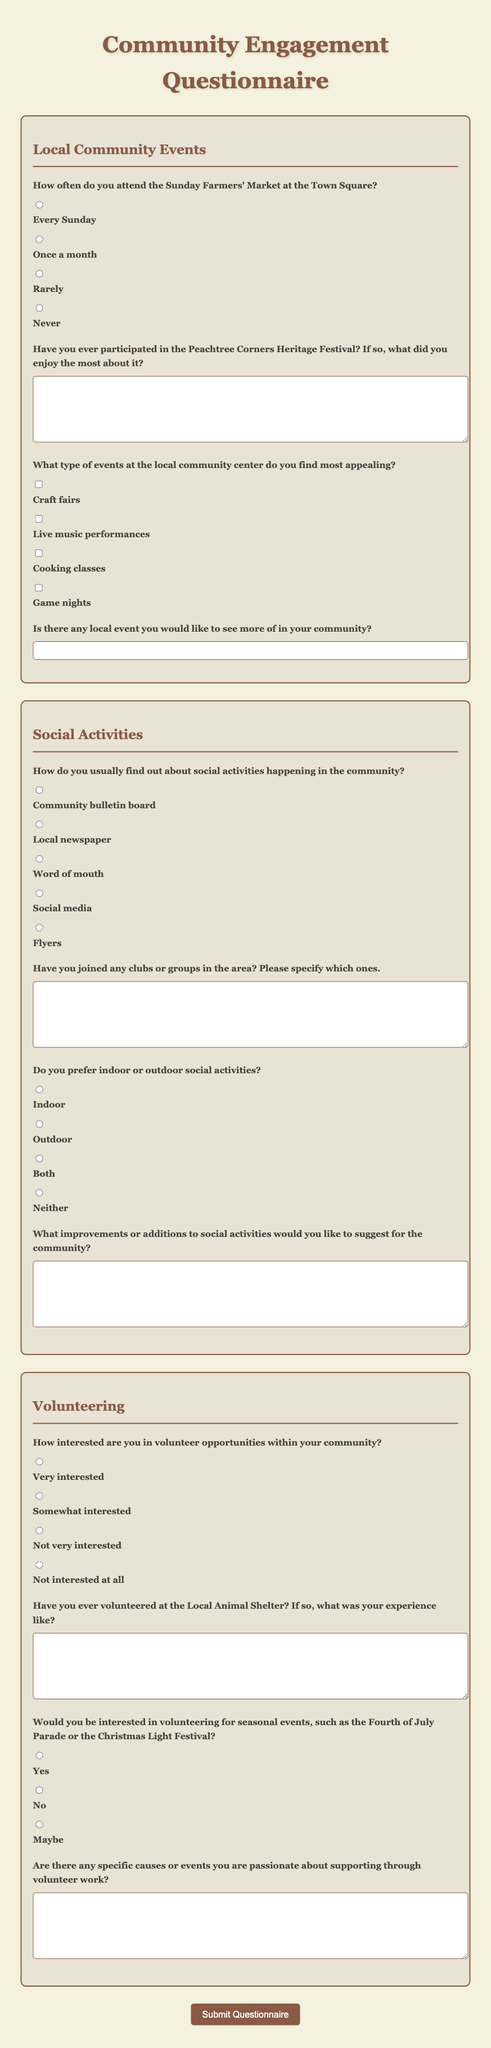How often do you attend the Sunday Farmers' Market at the Town Square? This question is directly asked in the document, targeting the frequency of attendance at the market.
Answer: Once a month What is the main topic of the first section in the questionnaire? The first section focuses on community events, specifically local community events.
Answer: Local Community Events What kind of events does the questionnaire ask about that might interest participants? The questionnaire lists types of events that could appeal to community members, specifically asking for preferences.
Answer: Craft fairs, Cooking classes, Game nights How do respondents typically find out about social activities? The questionnaire details various sources where individuals might learn about social activities in their community.
Answer: Community bulletin board What types of social activities do people prefer according to the document? The preference for social activities is categorized as indoor, outdoor, both, or neither.
Answer: Both 